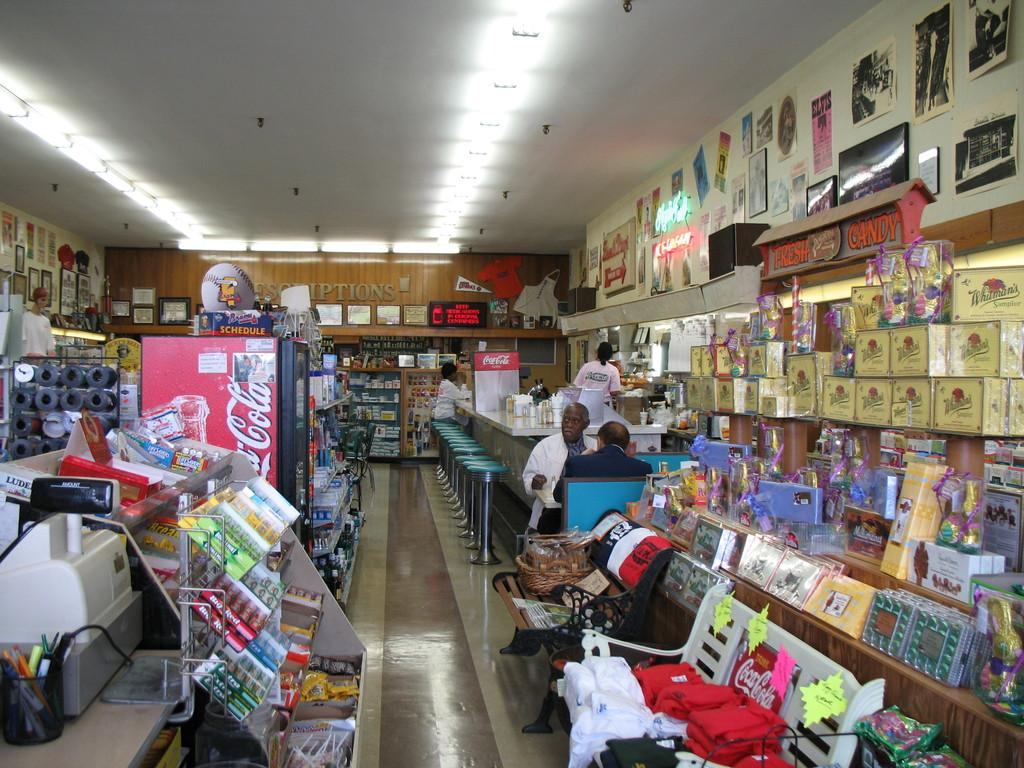Provide a one-sentence caption for the provided image. A diner with various items for sale and a Coca Cola drink cooler in the center. 